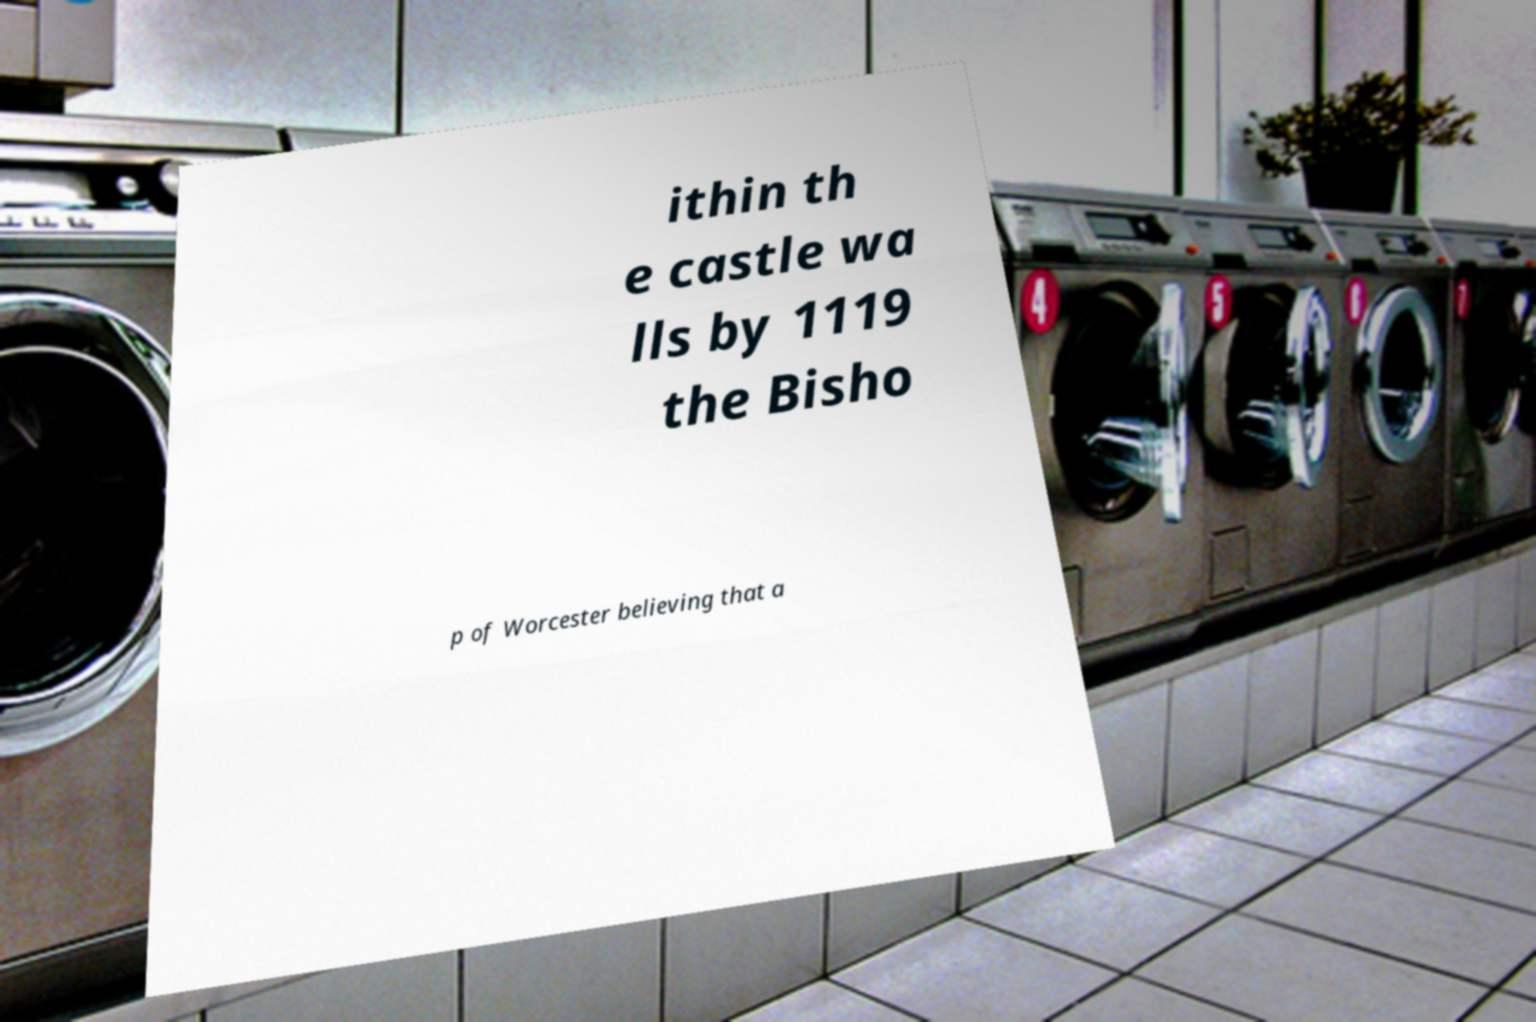Could you extract and type out the text from this image? ithin th e castle wa lls by 1119 the Bisho p of Worcester believing that a 